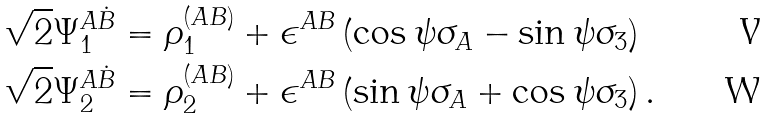Convert formula to latex. <formula><loc_0><loc_0><loc_500><loc_500>\sqrt { 2 } \Psi _ { 1 } ^ { A \dot { B } } & = \rho _ { 1 } ^ { ( A B ) } + \epsilon ^ { A B } \left ( \cos \psi \sigma _ { A } - \sin \psi \sigma _ { 3 } \right ) \\ \sqrt { 2 } \Psi _ { 2 } ^ { A \dot { B } } & = \rho _ { 2 } ^ { ( A B ) } + \epsilon ^ { A B } \left ( \sin \psi \sigma _ { A } + \cos \psi \sigma _ { 3 } \right ) .</formula> 